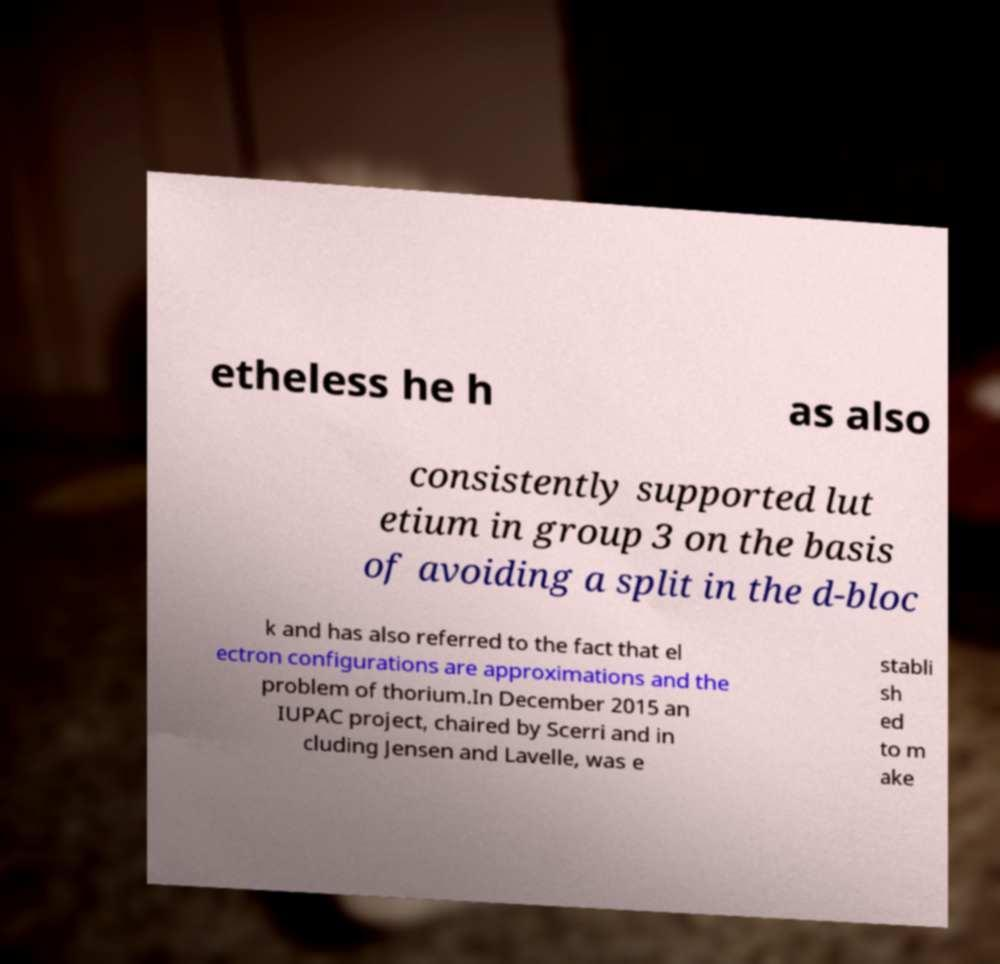There's text embedded in this image that I need extracted. Can you transcribe it verbatim? etheless he h as also consistently supported lut etium in group 3 on the basis of avoiding a split in the d-bloc k and has also referred to the fact that el ectron configurations are approximations and the problem of thorium.In December 2015 an IUPAC project, chaired by Scerri and in cluding Jensen and Lavelle, was e stabli sh ed to m ake 